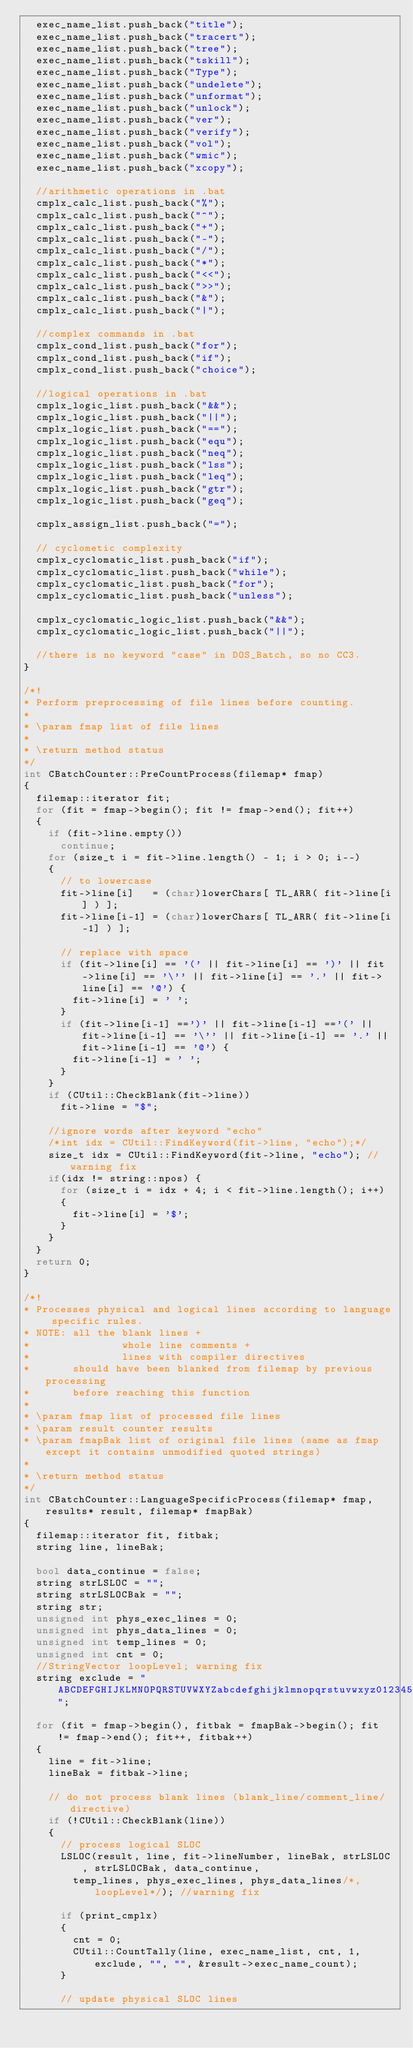<code> <loc_0><loc_0><loc_500><loc_500><_C++_>	exec_name_list.push_back("title");
	exec_name_list.push_back("tracert");
	exec_name_list.push_back("tree");
	exec_name_list.push_back("tskill");
	exec_name_list.push_back("Type");
	exec_name_list.push_back("undelete");
	exec_name_list.push_back("unformat");
	exec_name_list.push_back("unlock");
	exec_name_list.push_back("ver");
	exec_name_list.push_back("verify");
	exec_name_list.push_back("vol");
	exec_name_list.push_back("wmic");
	exec_name_list.push_back("xcopy");
	
	//arithmetic operations in .bat
	cmplx_calc_list.push_back("%");
	cmplx_calc_list.push_back("^");
	cmplx_calc_list.push_back("+");
	cmplx_calc_list.push_back("-");
	cmplx_calc_list.push_back("/");
	cmplx_calc_list.push_back("*");
	cmplx_calc_list.push_back("<<");
	cmplx_calc_list.push_back(">>");
	cmplx_calc_list.push_back("&");
	cmplx_calc_list.push_back("|");

	//complex commands in .bat
	cmplx_cond_list.push_back("for");
	cmplx_cond_list.push_back("if");
	cmplx_cond_list.push_back("choice");

	//logical operations in .bat
	cmplx_logic_list.push_back("&&");
	cmplx_logic_list.push_back("||");
	cmplx_logic_list.push_back("==");
	cmplx_logic_list.push_back("equ");
	cmplx_logic_list.push_back("neq");
	cmplx_logic_list.push_back("lss");
	cmplx_logic_list.push_back("leq");
	cmplx_logic_list.push_back("gtr");
	cmplx_logic_list.push_back("geq");

	cmplx_assign_list.push_back("=");

	// cyclometic complexity
	cmplx_cyclomatic_list.push_back("if");
	cmplx_cyclomatic_list.push_back("while");
	cmplx_cyclomatic_list.push_back("for");
	cmplx_cyclomatic_list.push_back("unless");

	cmplx_cyclomatic_logic_list.push_back("&&");
	cmplx_cyclomatic_logic_list.push_back("||");

	//there is no keyword "case" in DOS_Batch, so no CC3.
}

/*!
* Perform preprocessing of file lines before counting.
*
* \param fmap list of file lines
*
* \return method status
*/
int CBatchCounter::PreCountProcess(filemap* fmap)
{
	filemap::iterator fit;
	for (fit = fmap->begin(); fit != fmap->end(); fit++) 
	{
		if (fit->line.empty())
			continue;
		for (size_t i = fit->line.length() - 1; i > 0; i--)
		{
			// to lowercase
			fit->line[i]   = (char)lowerChars[ TL_ARR( fit->line[i] ) ];
			fit->line[i-1] = (char)lowerChars[ TL_ARR( fit->line[i-1] ) ];

			// replace with space
			if (fit->line[i] == '(' || fit->line[i] == ')' || fit->line[i] == '\'' || fit->line[i] == '.' || fit->line[i] == '@') {
				fit->line[i] = ' ';
			}
			if (fit->line[i-1] ==')' || fit->line[i-1] =='(' || fit->line[i-1] == '\'' || fit->line[i-1] == '.' || fit->line[i-1] == '@') {
				fit->line[i-1] = ' ';
			}
		}
		if (CUtil::CheckBlank(fit->line))
			fit->line = "$";
		
		//ignore words after keyword "echo"
		/*int idx = CUtil::FindKeyword(fit->line, "echo");*/
		size_t idx = CUtil::FindKeyword(fit->line, "echo"); // warning fix
		if(idx != string::npos) {
			for (size_t i = idx + 4; i < fit->line.length(); i++)
			{
				fit->line[i] = '$';
			}
		}
	}
	return 0;
}

/*!
* Processes physical and logical lines according to language specific rules.
* NOTE: all the blank lines +
*               whole line comments +
*               lines with compiler directives
*       should have been blanked from filemap by previous processing
*       before reaching this function
*
* \param fmap list of processed file lines
* \param result counter results
* \param fmapBak list of original file lines (same as fmap except it contains unmodified quoted strings)
*
* \return method status
*/
int CBatchCounter::LanguageSpecificProcess(filemap* fmap, results* result, filemap* fmapBak)
{
	filemap::iterator fit, fitbak;
	string line, lineBak;

	bool data_continue = false;
	string strLSLOC = "";
	string strLSLOCBak = "";
	string str;
	unsigned int phys_exec_lines = 0;
	unsigned int phys_data_lines = 0;
	unsigned int temp_lines = 0;
	unsigned int cnt = 0; 
	//StringVector loopLevel; warning fix
	string exclude = "ABCDEFGHIJKLMNOPQRSTUVWXYZabcdefghijklmnopqrstuvwxyz0123456789_$";

	for (fit = fmap->begin(), fitbak = fmapBak->begin(); fit != fmap->end(); fit++, fitbak++)
	{
		line = fit->line;
		lineBak = fitbak->line;

		// do not process blank lines (blank_line/comment_line/directive)
		if (!CUtil::CheckBlank(line))
		{
			// process logical SLOC
			LSLOC(result, line, fit->lineNumber, lineBak, strLSLOC, strLSLOCBak, data_continue,
				temp_lines, phys_exec_lines, phys_data_lines/*, loopLevel*/); //warning fix

			if (print_cmplx)
			{
				cnt = 0;
				CUtil::CountTally(line, exec_name_list, cnt, 1, exclude, "", "", &result->exec_name_count);
			}

			// update physical SLOC lines</code> 